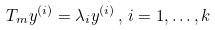Convert formula to latex. <formula><loc_0><loc_0><loc_500><loc_500>T _ { m } { y } ^ { ( i ) } = \lambda _ { i } { y } ^ { ( i ) } \, , \, i = 1 , \dots , k</formula> 